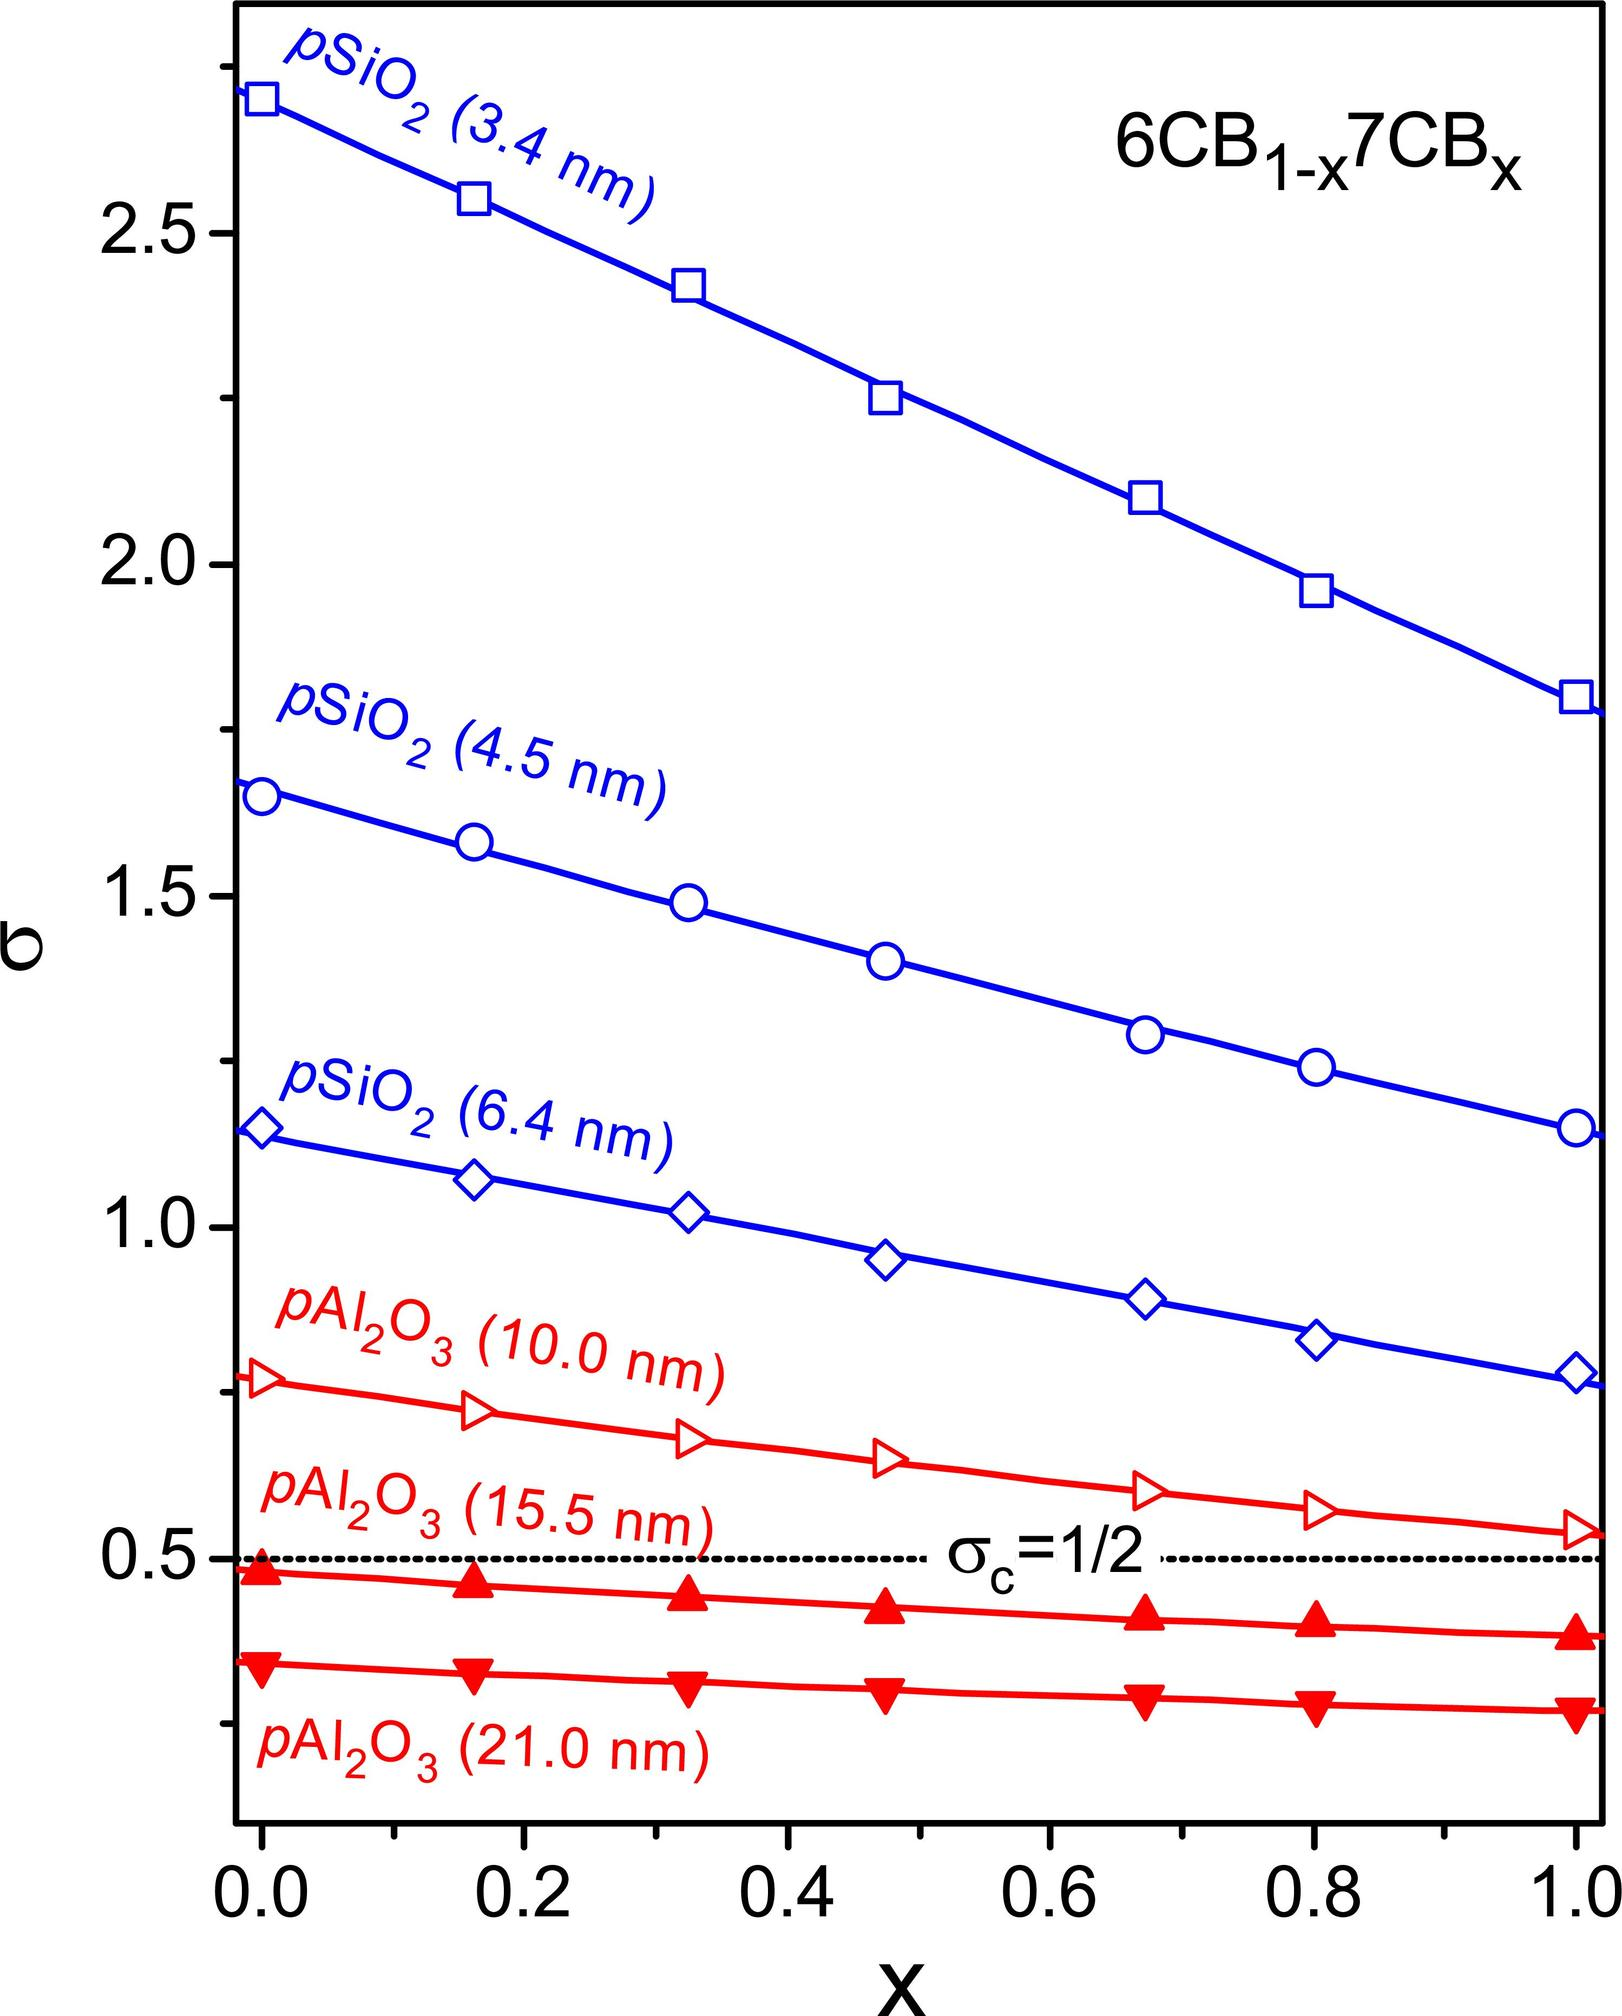Can you explain the significance of the different particle sizes mentioned for pSiO2 and pAl2O3 in the graph? Certainly! The graph displays various lines that correspond to different particle sizes of pSiO2 and pAl2O3, each measured in nanometers (nm). These particle sizes are significant because they influence the confining effect these particles have on the 6CB/7CB liquid crystal mixture. Smaller particles generally impose a stronger confining influence due to a higher surface area relative to volume, which can affect the mixture's phase behavior. Therefore, understanding how different sizes interact with the liquid crystal components can be essential in material science, especially when designing materials with specific properties. 